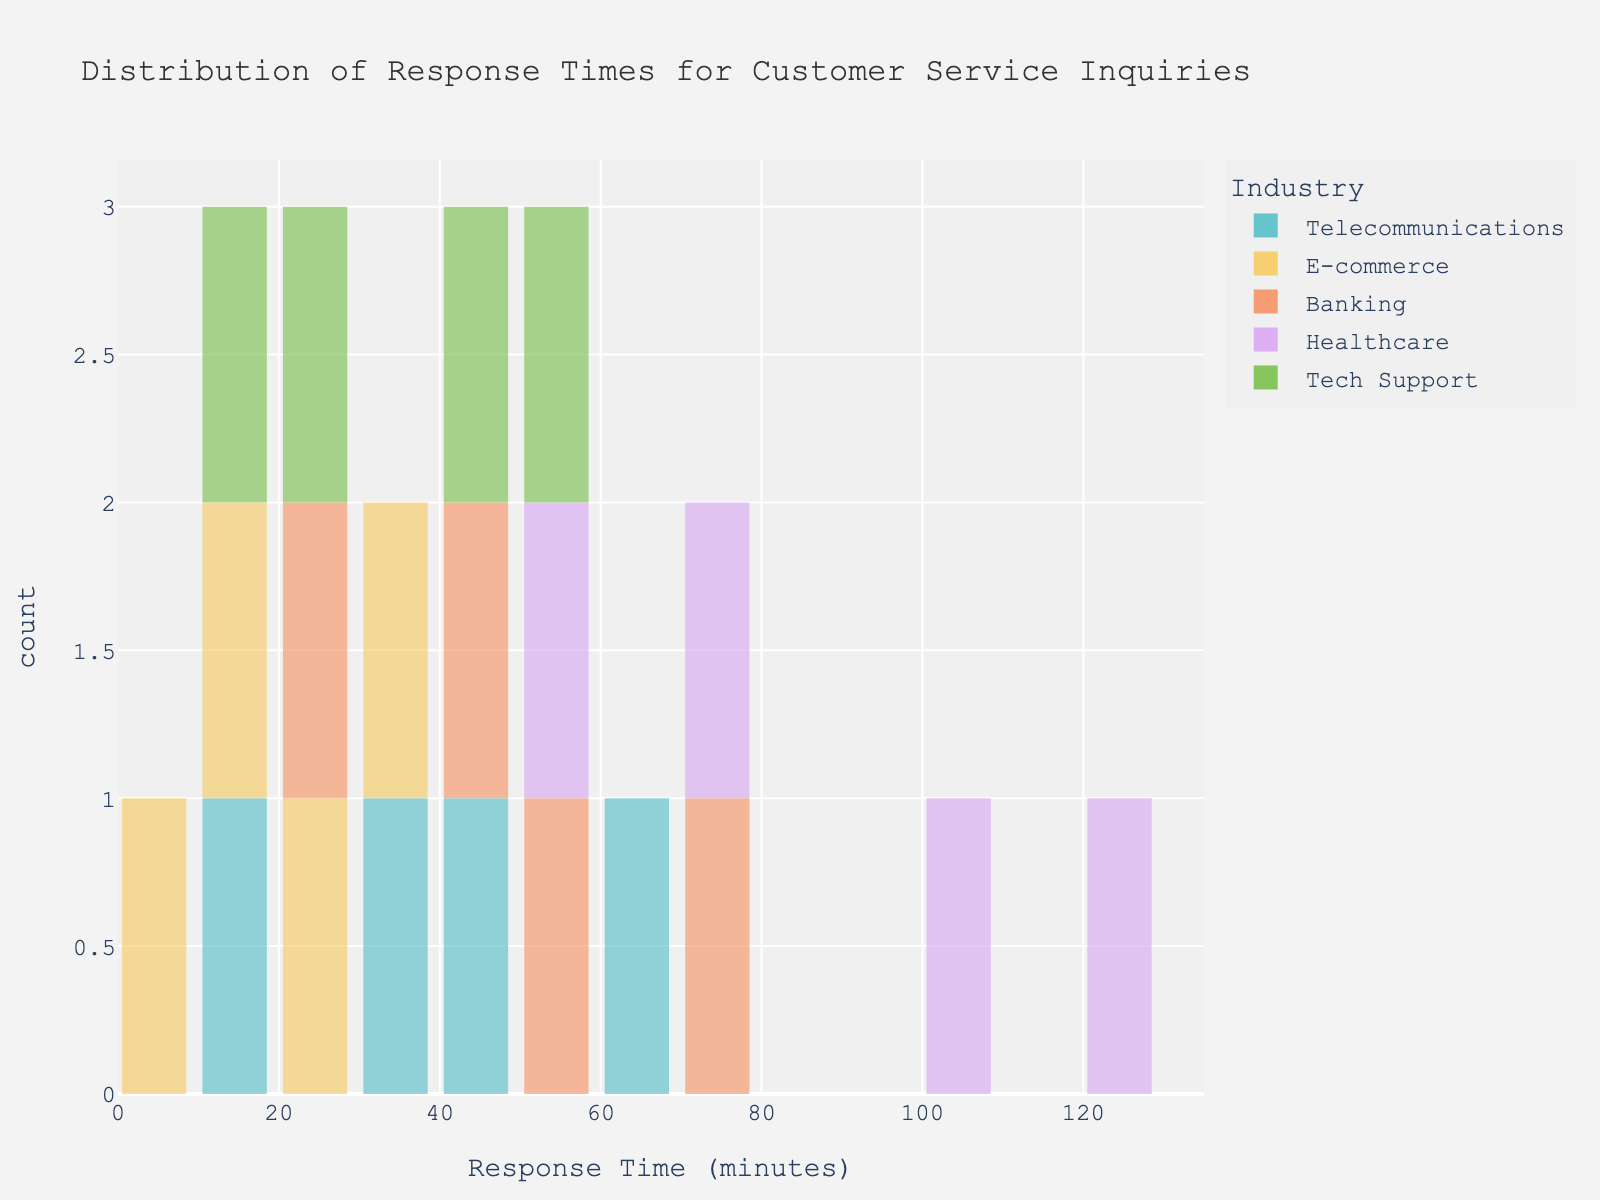What is the title of the histogram? The title is usually at the top of the histogram and provides a summary of what the graph is about.
Answer: Distribution of Response Times for Customer Service Inquiries How many bins are there in the histogram? Bins are the individual bars in the histogram. Count the number of bars displayed.
Answer: 20 Which industry has the lowest response time? Identify the shortest response time and then look at the color to determine which industry it corresponds to.
Answer: E-commerce What's the range of response times covered in the histogram? Look at the x-axis from the minimum value to the maximum value displayed.
Answer: 0 to 130 minutes Which industry shows the most variation in response times? The industry with the widest spread of bars on the x-axis demonstrates the most variation.
Answer: Healthcare Compare the highest response time in Healthcare and Tech Support industries. Which is greater and by how much? Identify the highest response time for Healthcare and Tech Support, then subtract the Tech Support value from the Healthcare value.
Answer: Healthcare is greater by 70 minutes (125 - 55) What is the most frequent response time bucket for Telecommunications? Check the tallest bar colored for Telecommunications to find the response time bucket with the highest frequency.
Answer: 15-30 minutes What is the overall range of response times for the Banking industry? Identify the smallest and largest response times in the Banking industry and then find the difference.
Answer: 25 to 70 minutes, range of 45 minutes Which industry has a peak response time around 40 minutes? Look for a bar around 40 minutes and determine the industry based on the color of the bar.
Answer: Banking By how much does the highest response time in the E-commerce industry differ from the lowest response time in the Telecommunications industry? Identify the highest response time in E-commerce and the lowest in Telecommunications, then subtract the E-commerce value from the Telecommunications value.
Answer: 5 minutes (10 - 15) 